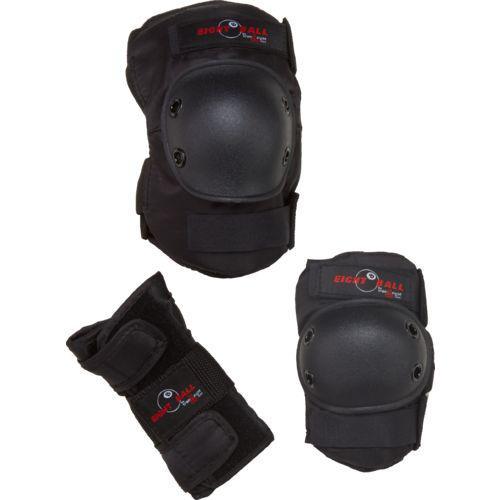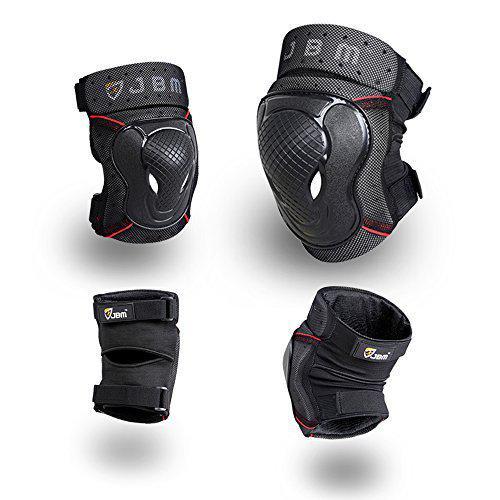The first image is the image on the left, the second image is the image on the right. Given the left and right images, does the statement "There is a red marking on at least one of the knee pads in the image on the right side." hold true? Answer yes or no. Yes. The first image is the image on the left, the second image is the image on the right. Assess this claim about the two images: "An image shows exactly three pads, which are not arranged in one horizontal row.". Correct or not? Answer yes or no. Yes. 